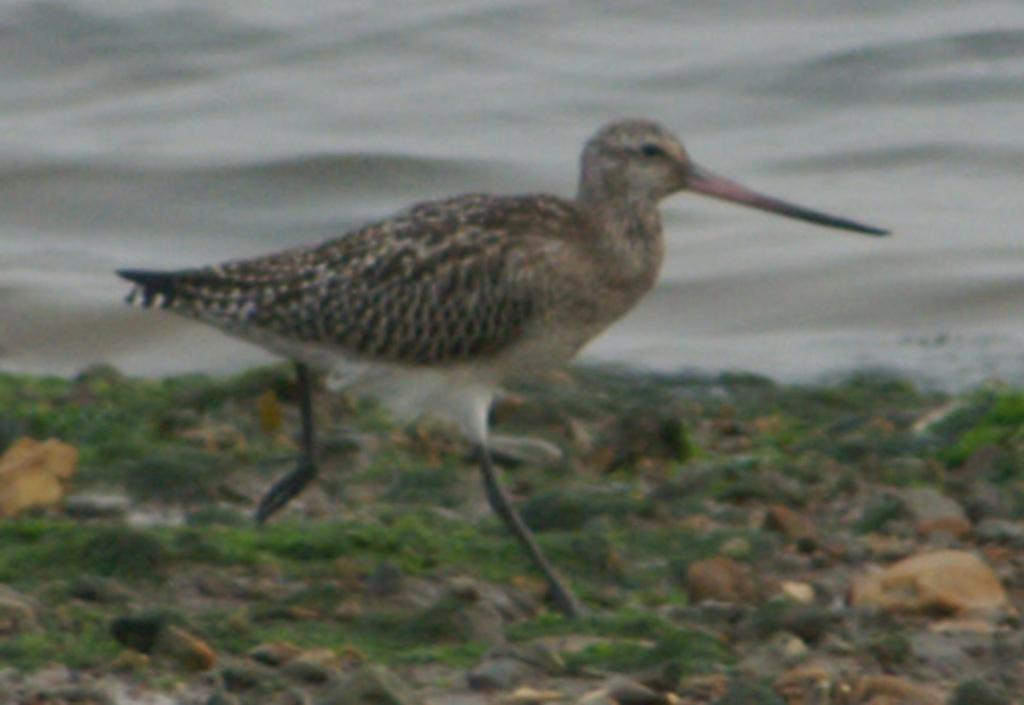How would you summarize this image in a sentence or two? In the center of the image we can see a bird. At the bottom of the image we can see some stones and grass. At the top of the image we can see the water. 